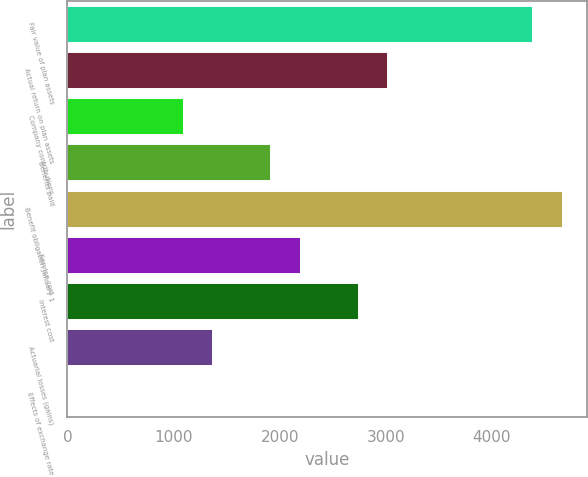Convert chart. <chart><loc_0><loc_0><loc_500><loc_500><bar_chart><fcel>Fair value of plan assets<fcel>Actual return on plan assets<fcel>Company contributions<fcel>Benefits paid<fcel>Benefit obligation January 1<fcel>Service cost<fcel>Interest cost<fcel>Actuarial losses (gains)<fcel>Effects of exchange rate<nl><fcel>4390.8<fcel>3019.3<fcel>1099.2<fcel>1922.1<fcel>4665.1<fcel>2196.4<fcel>2745<fcel>1373.5<fcel>2<nl></chart> 